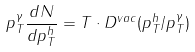Convert formula to latex. <formula><loc_0><loc_0><loc_500><loc_500>p _ { T } ^ { \gamma } \frac { d N } { d p _ { T } ^ { h } } = T \cdot D ^ { v a c } ( p _ { T } ^ { h } / p _ { T } ^ { \gamma } )</formula> 